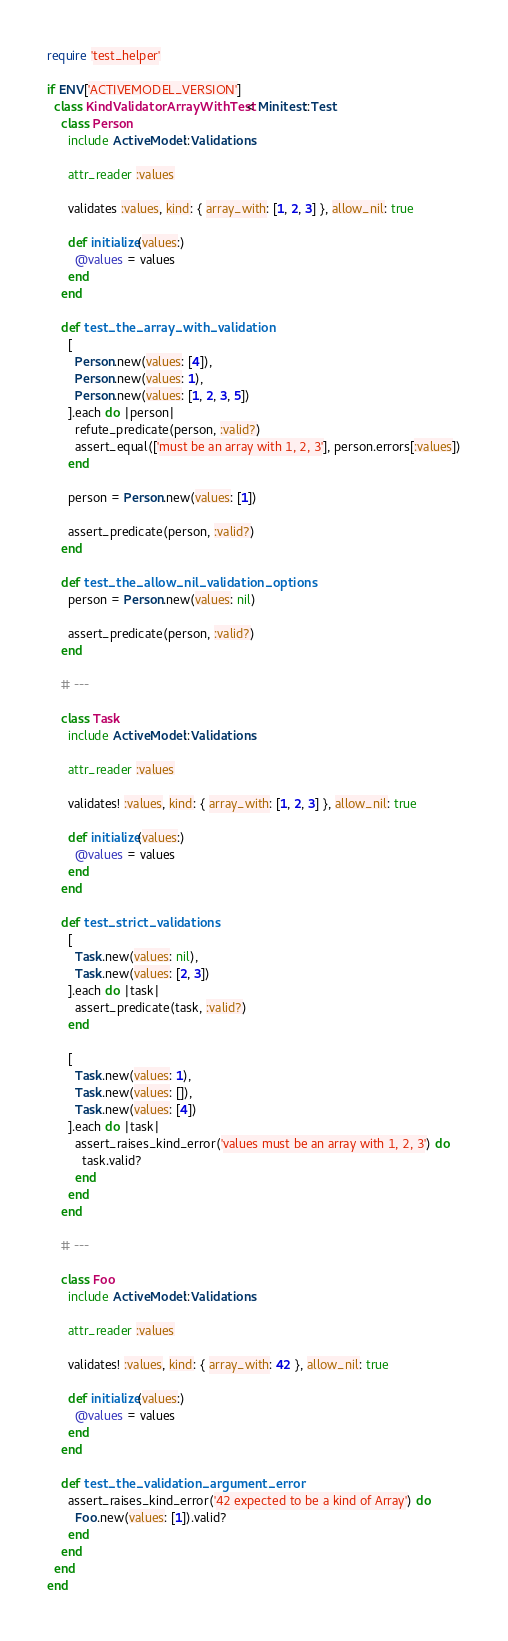<code> <loc_0><loc_0><loc_500><loc_500><_Ruby_>require 'test_helper'

if ENV['ACTIVEMODEL_VERSION']
  class KindValidatorArrayWithTest < Minitest::Test
    class Person
      include ActiveModel::Validations

      attr_reader :values

      validates :values, kind: { array_with: [1, 2, 3] }, allow_nil: true

      def initialize(values:)
        @values = values
      end
    end

    def test_the_array_with_validation
      [
        Person.new(values: [4]),
        Person.new(values: 1),
        Person.new(values: [1, 2, 3, 5])
      ].each do |person|
        refute_predicate(person, :valid?)
        assert_equal(['must be an array with 1, 2, 3'], person.errors[:values])
      end

      person = Person.new(values: [1])

      assert_predicate(person, :valid?)
    end

    def test_the_allow_nil_validation_options
      person = Person.new(values: nil)

      assert_predicate(person, :valid?)
    end

    # ---

    class Task
      include ActiveModel::Validations

      attr_reader :values

      validates! :values, kind: { array_with: [1, 2, 3] }, allow_nil: true

      def initialize(values:)
        @values = values
      end
    end

    def test_strict_validations
      [
        Task.new(values: nil),
        Task.new(values: [2, 3])
      ].each do |task|
        assert_predicate(task, :valid?)
      end

      [
        Task.new(values: 1),
        Task.new(values: []),
        Task.new(values: [4])
      ].each do |task|
        assert_raises_kind_error('values must be an array with 1, 2, 3') do
          task.valid?
        end
      end
    end

    # ---

    class Foo
      include ActiveModel::Validations

      attr_reader :values

      validates! :values, kind: { array_with: 42 }, allow_nil: true

      def initialize(values:)
        @values = values
      end
    end

    def test_the_validation_argument_error
      assert_raises_kind_error('42 expected to be a kind of Array') do
        Foo.new(values: [1]).valid?
      end
    end
  end
end
</code> 